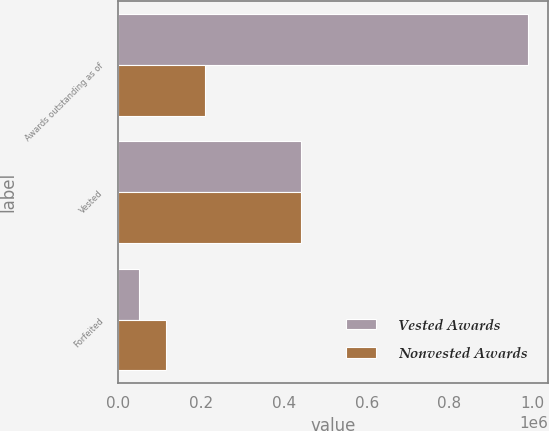Convert chart to OTSL. <chart><loc_0><loc_0><loc_500><loc_500><stacked_bar_chart><ecel><fcel>Awards outstanding as of<fcel>Vested<fcel>Forfeited<nl><fcel>Vested Awards<fcel>989414<fcel>442274<fcel>50076<nl><fcel>Nonvested Awards<fcel>208916<fcel>442274<fcel>116675<nl></chart> 